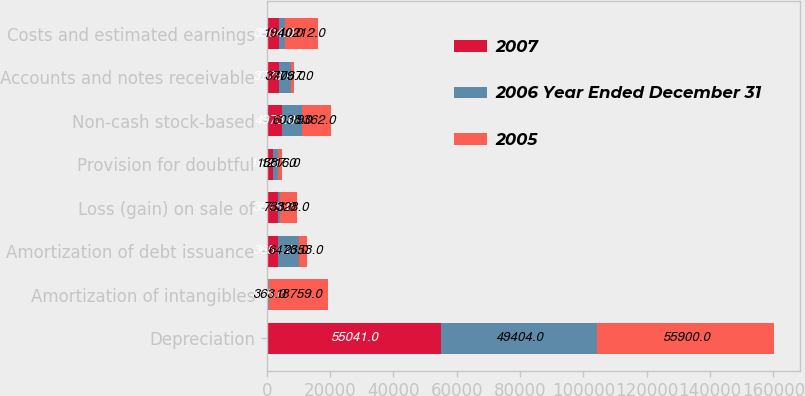<chart> <loc_0><loc_0><loc_500><loc_500><stacked_bar_chart><ecel><fcel>Depreciation<fcel>Amortization of intangibles<fcel>Amortization of debt issuance<fcel>Loss (gain) on sale of<fcel>Provision for doubtful<fcel>Non-cash stock-based<fcel>Accounts and notes receivable<fcel>Costs and estimated earnings<nl><fcel>2007<fcel>55041<fcel>365<fcel>3654<fcel>3515<fcel>1988<fcel>4973<fcel>3779<fcel>3904<nl><fcel>2006 Year Ended December 31<fcel>49404<fcel>363<fcel>6473<fcel>733<fcel>1587<fcel>6038<fcel>3779<fcel>1940<nl><fcel>2005<fcel>55900<fcel>18759<fcel>2653<fcel>5328<fcel>1216<fcel>9362<fcel>1037<fcel>10212<nl></chart> 